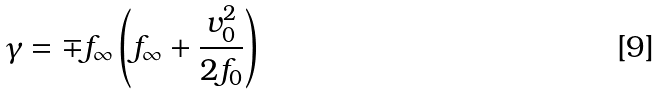Convert formula to latex. <formula><loc_0><loc_0><loc_500><loc_500>\gamma = \mp f _ { \infty } \left ( f _ { \infty } + { \frac { v _ { 0 } ^ { 2 } } { 2 f _ { 0 } } } \right )</formula> 